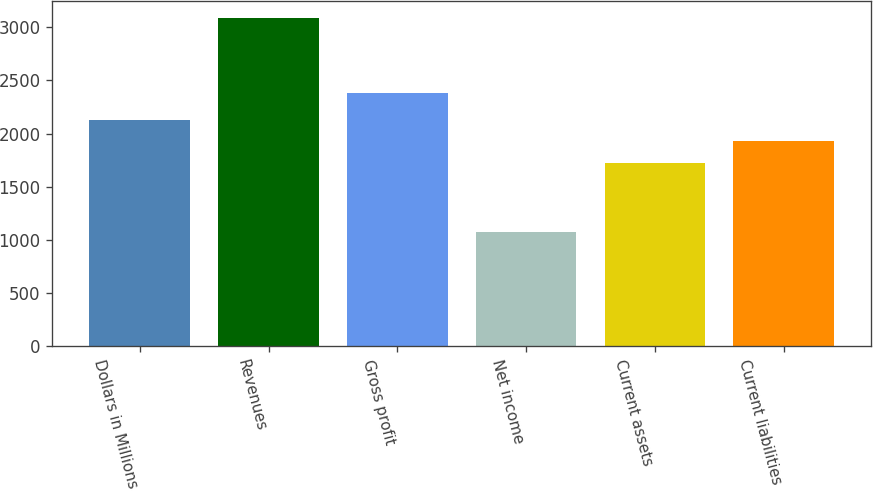<chart> <loc_0><loc_0><loc_500><loc_500><bar_chart><fcel>Dollars in Millions<fcel>Revenues<fcel>Gross profit<fcel>Net income<fcel>Current assets<fcel>Current liabilities<nl><fcel>2131<fcel>3090<fcel>2379<fcel>1070<fcel>1727<fcel>1929<nl></chart> 